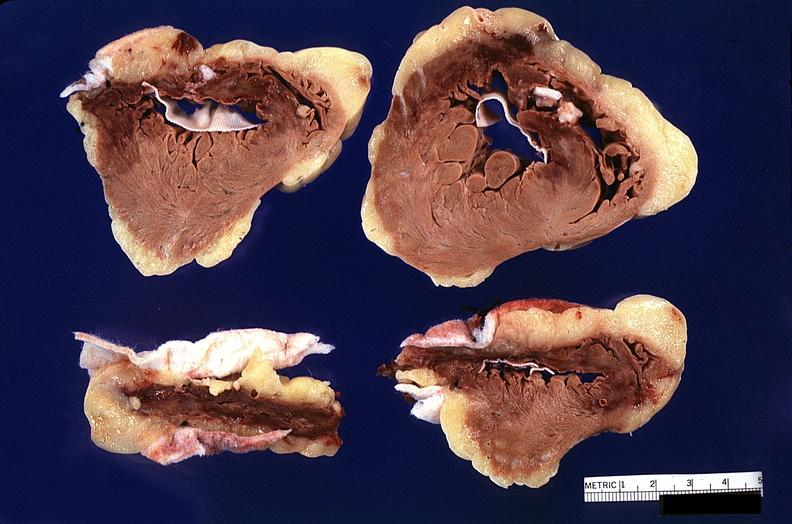does amyloidosis show heart, myocardial infarction, surgery to repair interventricular septum rupture?
Answer the question using a single word or phrase. No 